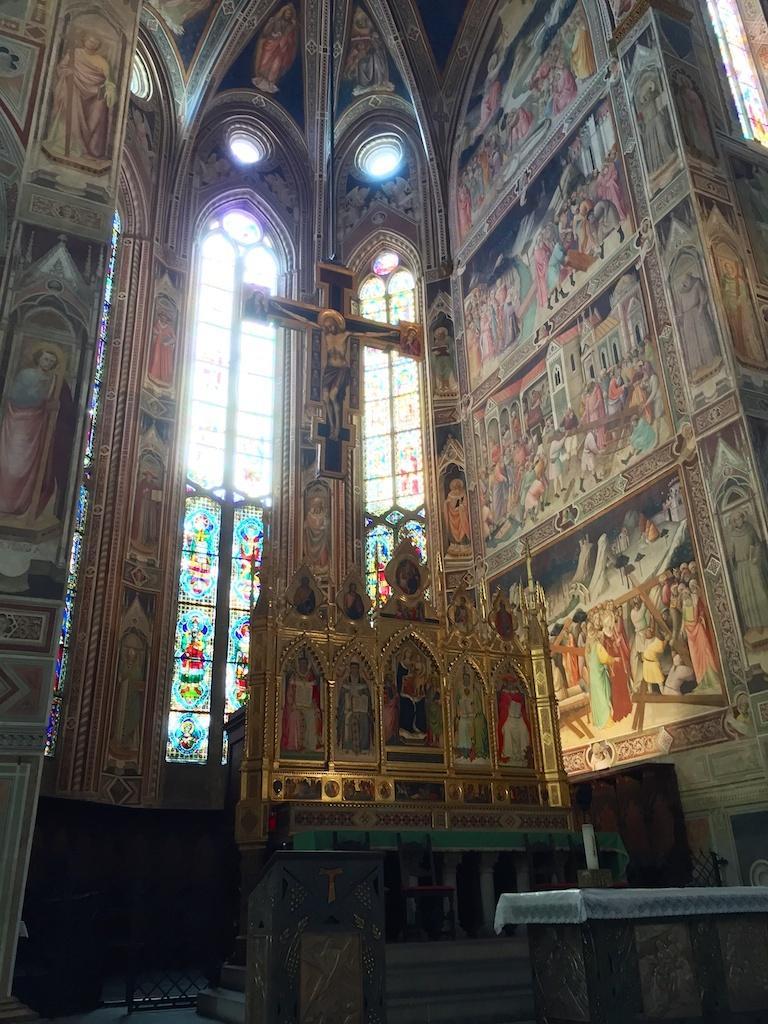How would you summarize this image in a sentence or two? In this image we can see pictures on the walls, windows, designs on the glasses, statue of a person on a cross symbol, object on a table at the bottom and we can see other objects. 